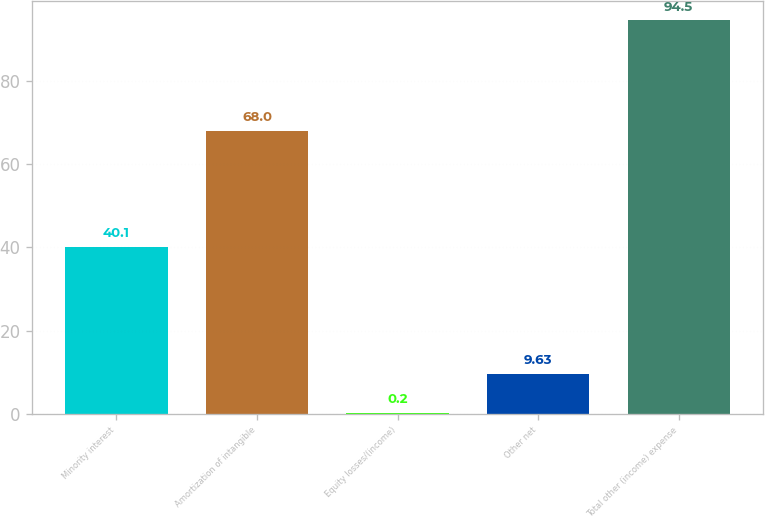<chart> <loc_0><loc_0><loc_500><loc_500><bar_chart><fcel>Minority interest<fcel>Amortization of intangible<fcel>Equity losses/(income)<fcel>Other net<fcel>Total other (income) expense<nl><fcel>40.1<fcel>68<fcel>0.2<fcel>9.63<fcel>94.5<nl></chart> 